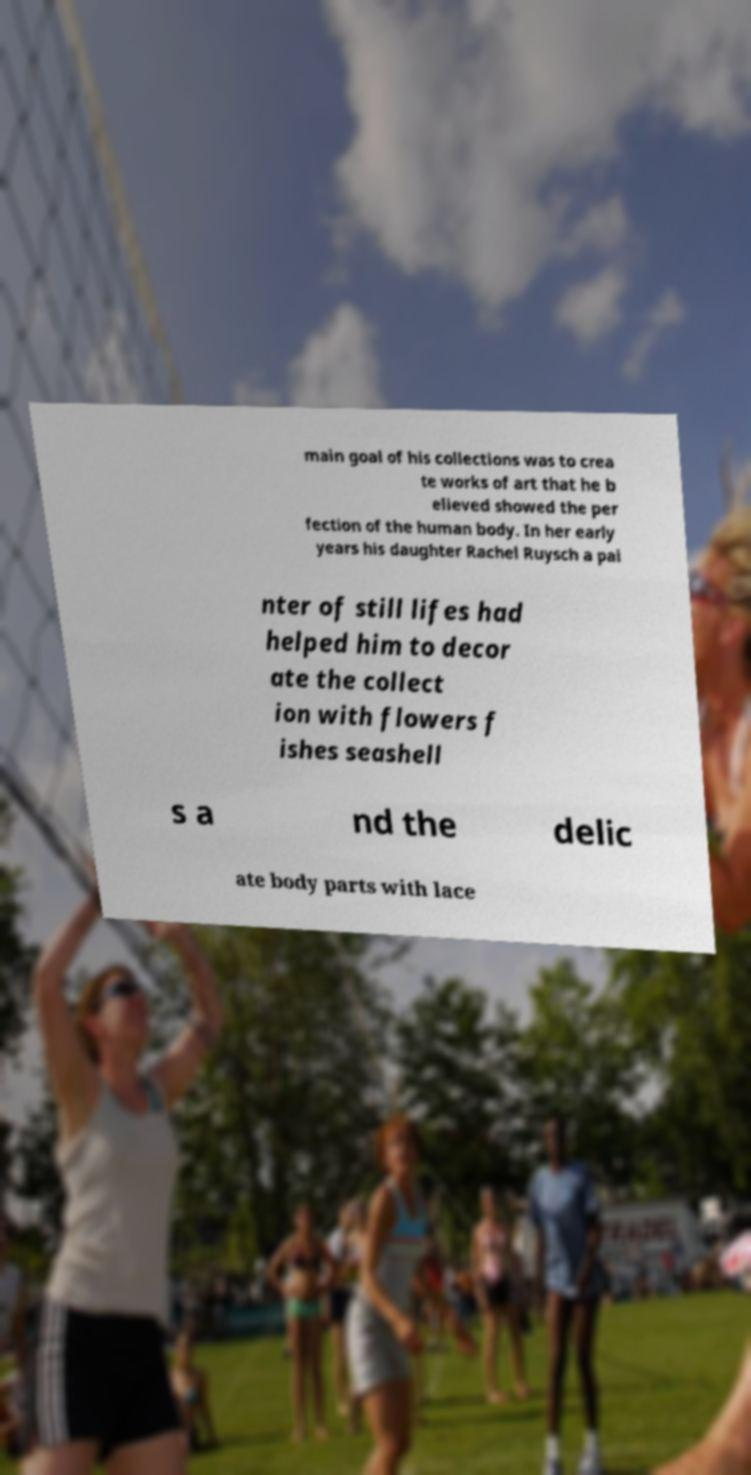Please read and relay the text visible in this image. What does it say? main goal of his collections was to crea te works of art that he b elieved showed the per fection of the human body. In her early years his daughter Rachel Ruysch a pai nter of still lifes had helped him to decor ate the collect ion with flowers f ishes seashell s a nd the delic ate body parts with lace 